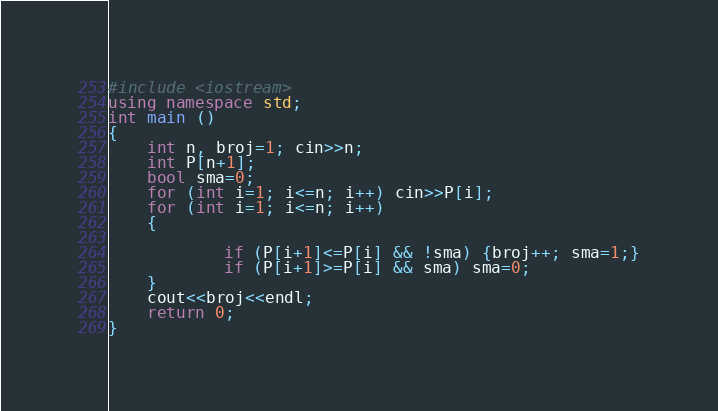Convert code to text. <code><loc_0><loc_0><loc_500><loc_500><_C++_>#include <iostream>
using namespace std;
int main ()
{
	int n, broj=1; cin>>n;
	int P[n+1];
	bool sma=0;
	for (int i=1; i<=n; i++) cin>>P[i];
	for (int i=1; i<=n; i++)
	{
		
			if (P[i+1]<=P[i] && !sma) {broj++; sma=1;}
			if (P[i+1]>=P[i] && sma) sma=0;
	}
	cout<<broj<<endl;
	return 0;
}</code> 